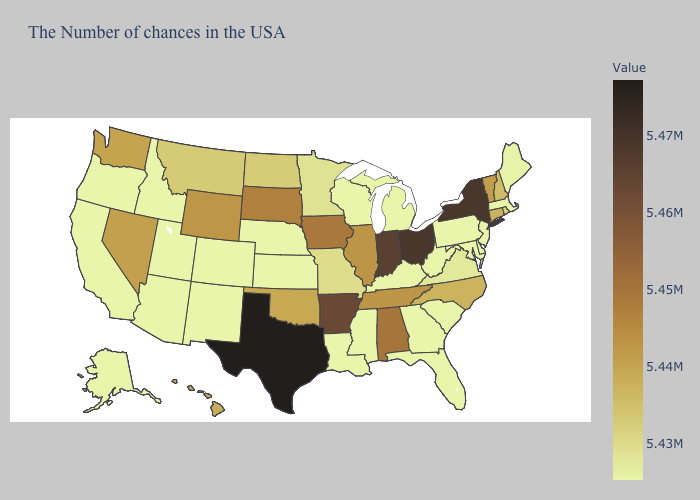Among the states that border Florida , which have the lowest value?
Write a very short answer. Georgia. Among the states that border Ohio , which have the highest value?
Be succinct. Indiana. Does Illinois have the lowest value in the USA?
Give a very brief answer. No. Among the states that border New Jersey , which have the lowest value?
Short answer required. Delaware, Pennsylvania. Does Ohio have the highest value in the MidWest?
Quick response, please. Yes. Which states hav the highest value in the MidWest?
Keep it brief. Ohio. 